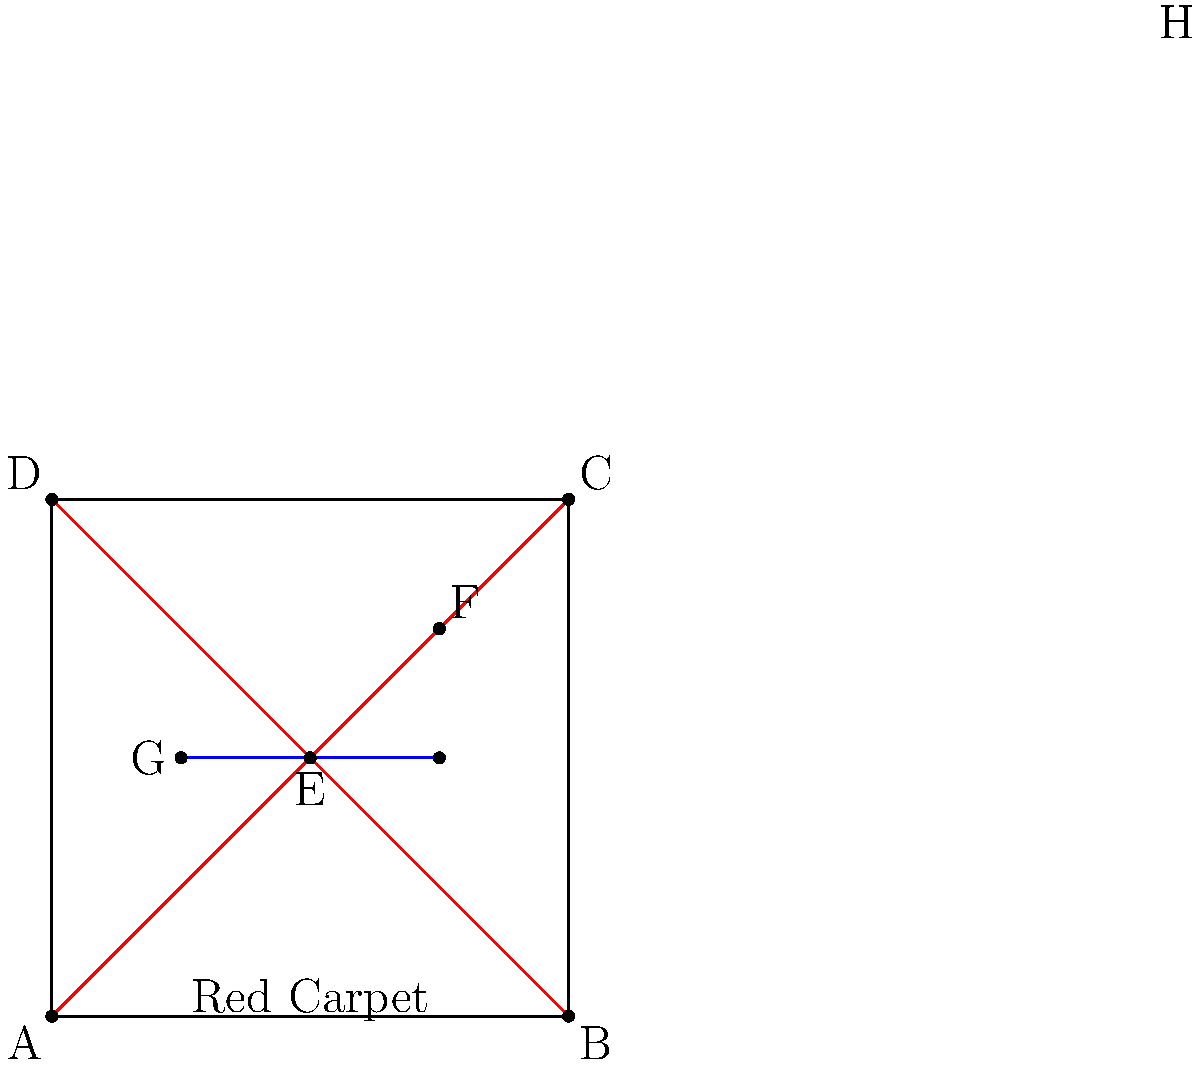In this red carpet scene from one of Pierce Brosnan's premieres, the red lines represent the edges of the carpet, and the blue line represents a row of photographers. If the angle between the red lines at point E is 90°, what is the relationship between the blue line GH and the vanishing point F? To solve this question, let's follow these steps:

1. Identify the vanishing point: In this perspective drawing, the vanishing point is F, where the red lines converge.

2. Recognize the properties of vanishing points: All lines parallel to each other in the real world will converge at the same vanishing point in a perspective drawing.

3. Analyze the red lines: The red lines represent the edges of the red carpet. They converge at point F, indicating they are parallel in the real world.

4. Examine the blue line: The blue line GH represents a row of photographers.

5. Consider the angle at point E: We're told that the angle between the red lines at point E is 90°. This implies that the red carpet edges are perpendicular in the real world.

6. Apply the principle of vanishing points: If the blue line GH is parallel to either of the red carpet edges in the real world, it would converge at the same vanishing point F.

7. Observe the blue line in the drawing: The blue line GH does not appear to be converging towards point F. Instead, it's drawn parallel to the bottom edge of the image.

8. Conclude: Since the blue line doesn't converge at F, it is not parallel to either of the red carpet edges in the real world. In the perspective of the scene, it appears as a horizontal line, which means it's perpendicular to the line of sight (the line from the viewer to the vanishing point).
Answer: The blue line GH is perpendicular to the line of sight towards the vanishing point F. 